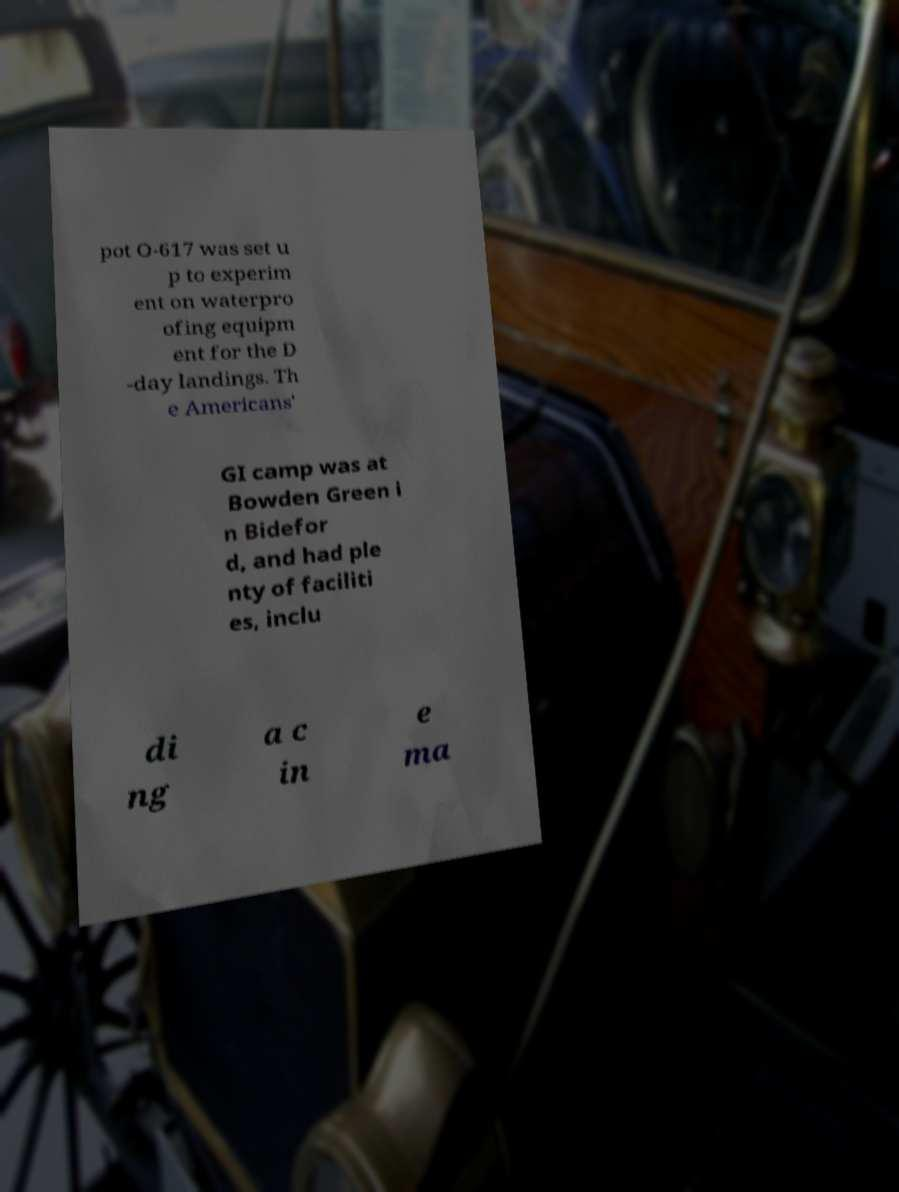Please read and relay the text visible in this image. What does it say? pot O-617 was set u p to experim ent on waterpro ofing equipm ent for the D -day landings. Th e Americans' GI camp was at Bowden Green i n Bidefor d, and had ple nty of faciliti es, inclu di ng a c in e ma 